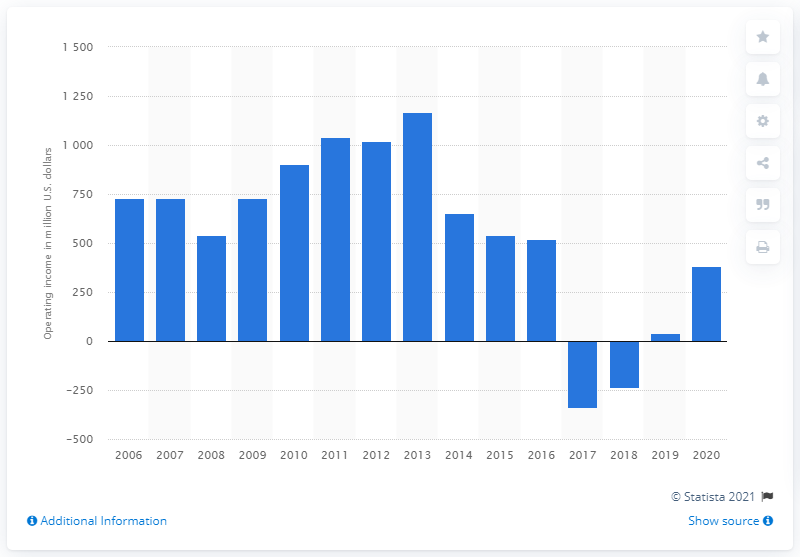Draw attention to some important aspects in this diagram. Mattel's operating income in dollars in 2020 was 380.9 million. 